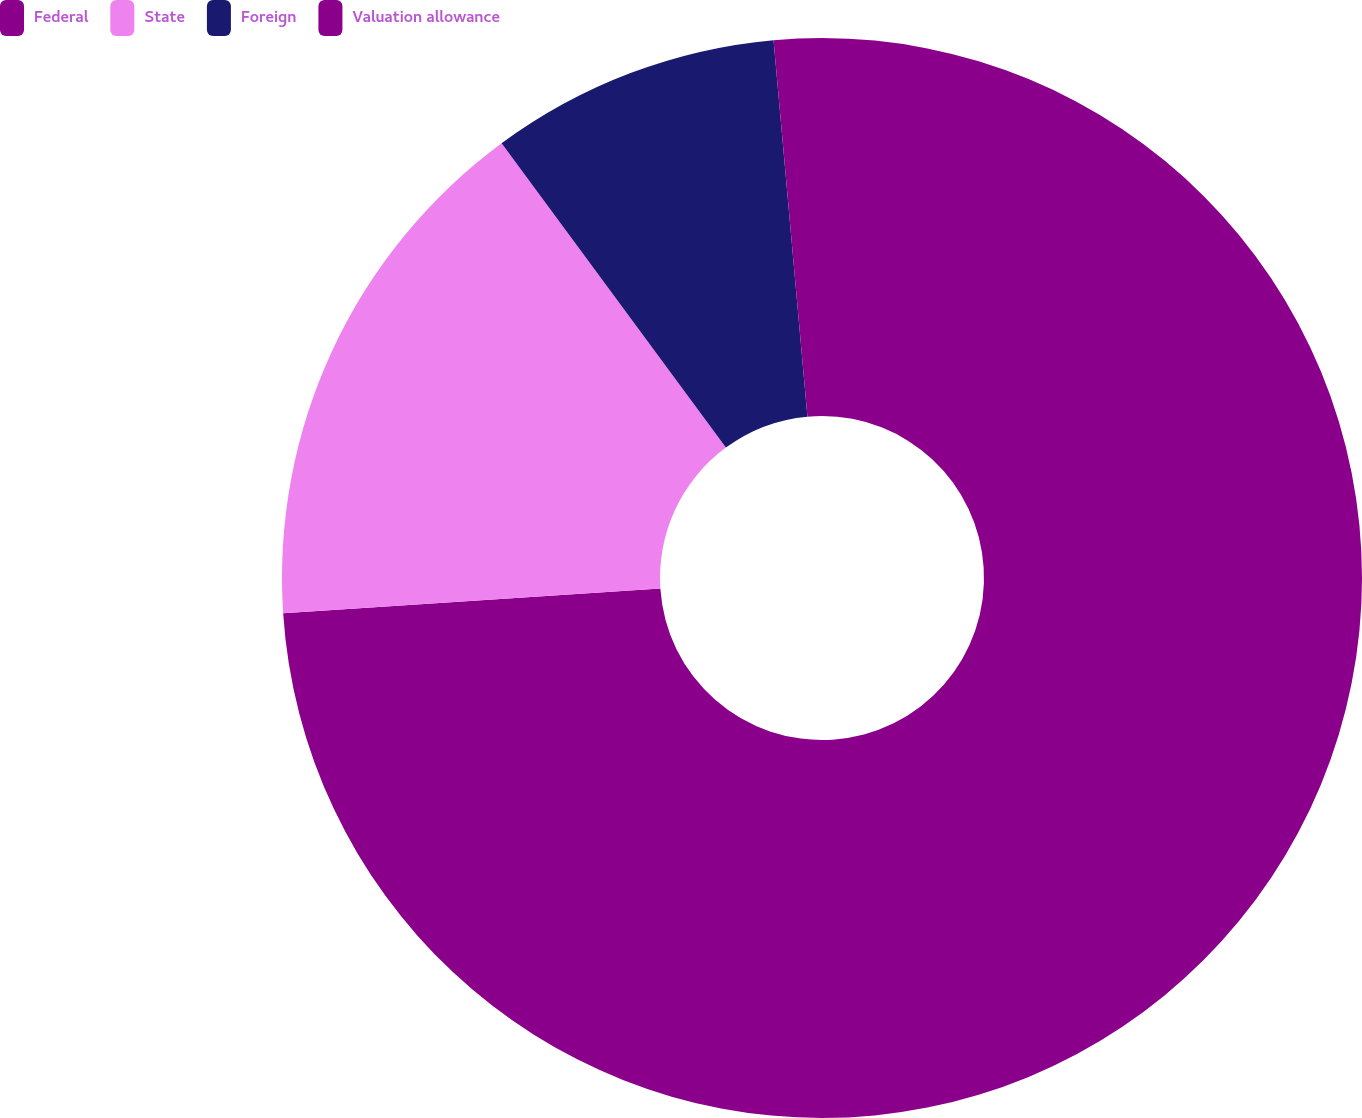<chart> <loc_0><loc_0><loc_500><loc_500><pie_chart><fcel>Federal<fcel>State<fcel>Foreign<fcel>Valuation allowance<nl><fcel>73.96%<fcel>15.93%<fcel>8.68%<fcel>1.43%<nl></chart> 